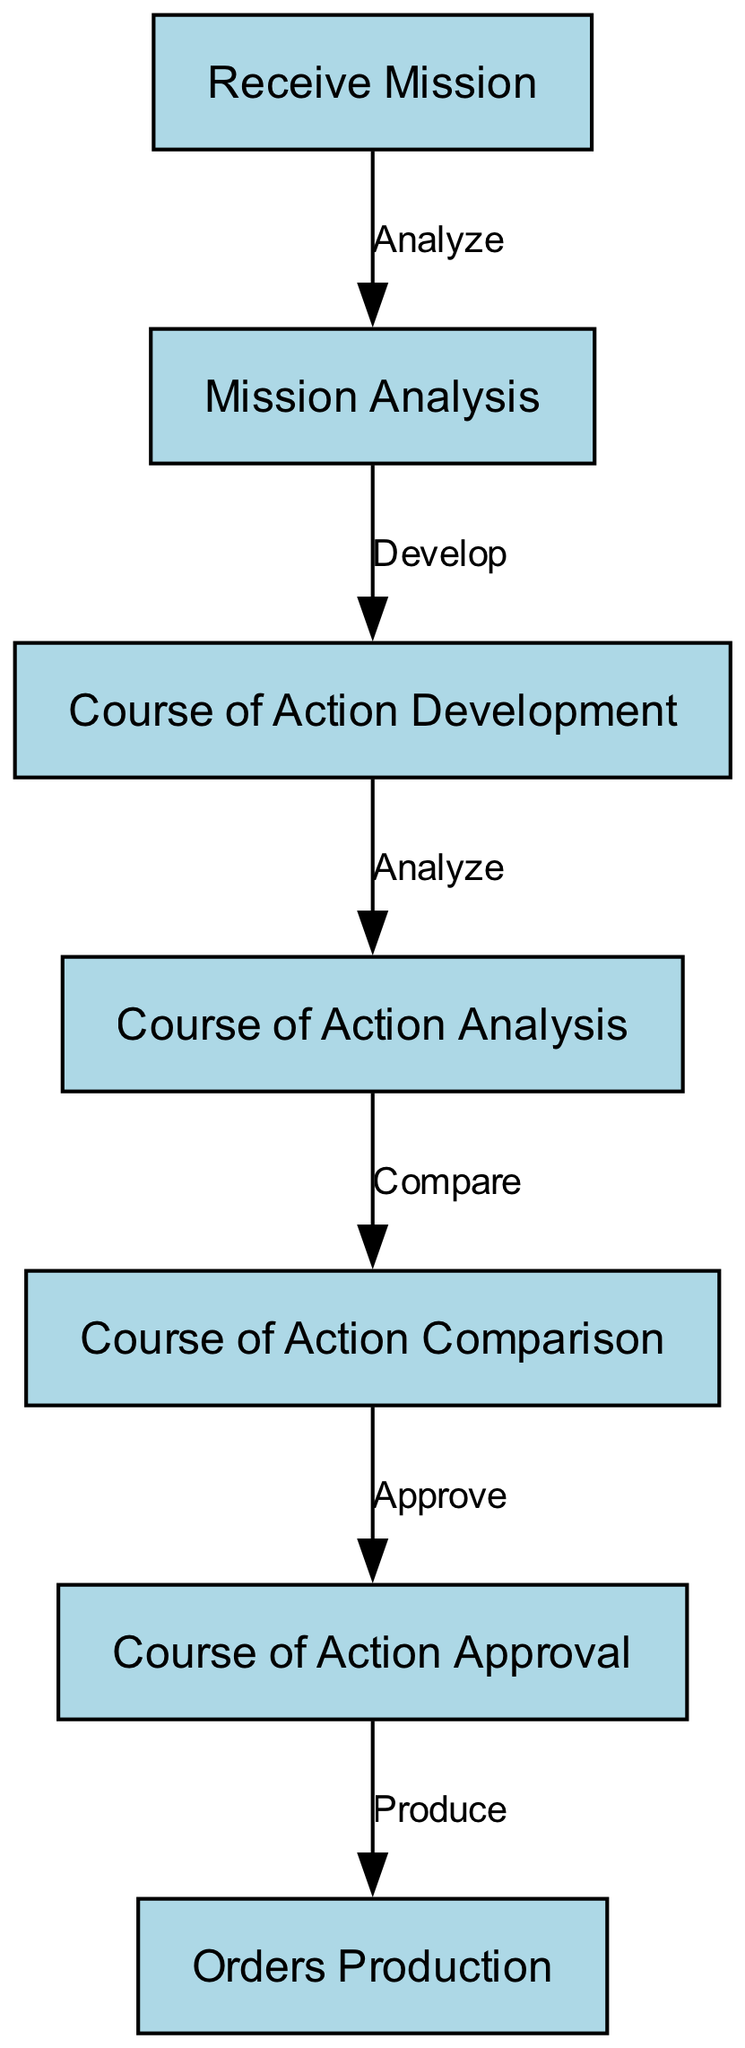What is the first node in the diagram? The first node in the diagram is identified as "Receive Mission," which appears at the top of the flowchart, indicating the starting point of the military decision-making process.
Answer: Receive Mission How many nodes are present in the diagram? The diagram contains a total of seven nodes, as counted from the list provided in the data, including all stages of the military decision-making process.
Answer: 7 What action is represented by the edge from node 2 to node 3? The edge from node 2 (Mission Analysis) to node 3 (Course of Action Development) is labeled "Develop," indicating the action taken between these two steps in the decision-making process.
Answer: Develop What is the last node in the flowchart? The last node in the flowchart is "Orders Production," which is the final step in the military decision-making process according to the provided sequence of actions.
Answer: Orders Production Which node receives approval? The node that receives approval is "Course of Action Approval," which is before the final step of orders production and is crucial for proceeding in the process.
Answer: Course of Action Approval What action is taken after course of action comparison? After the "Course of Action Comparison," the action taken is "Approve," as shown by the edge connecting these two nodes, leading to the next step of approval.
Answer: Approve What is the relationship between node 4 and node 5? The relationship between node 4 (Course of Action Analysis) and node 5 (Course of Action Comparison) is defined by the action labeled "Compare," indicating that the analysis leads to a comparison of the developed courses of action.
Answer: Compare Which node precedes orders production? The node that precedes "Orders Production" is "Course of Action Approval," highlighting the necessary approval before moving to the production of orders.
Answer: Course of Action Approval What action connects the last two nodes in the diagram? The last two nodes are connected by the action "Produce," which indicates that orders are created after receiving approval from the previous step in the process.
Answer: Produce 